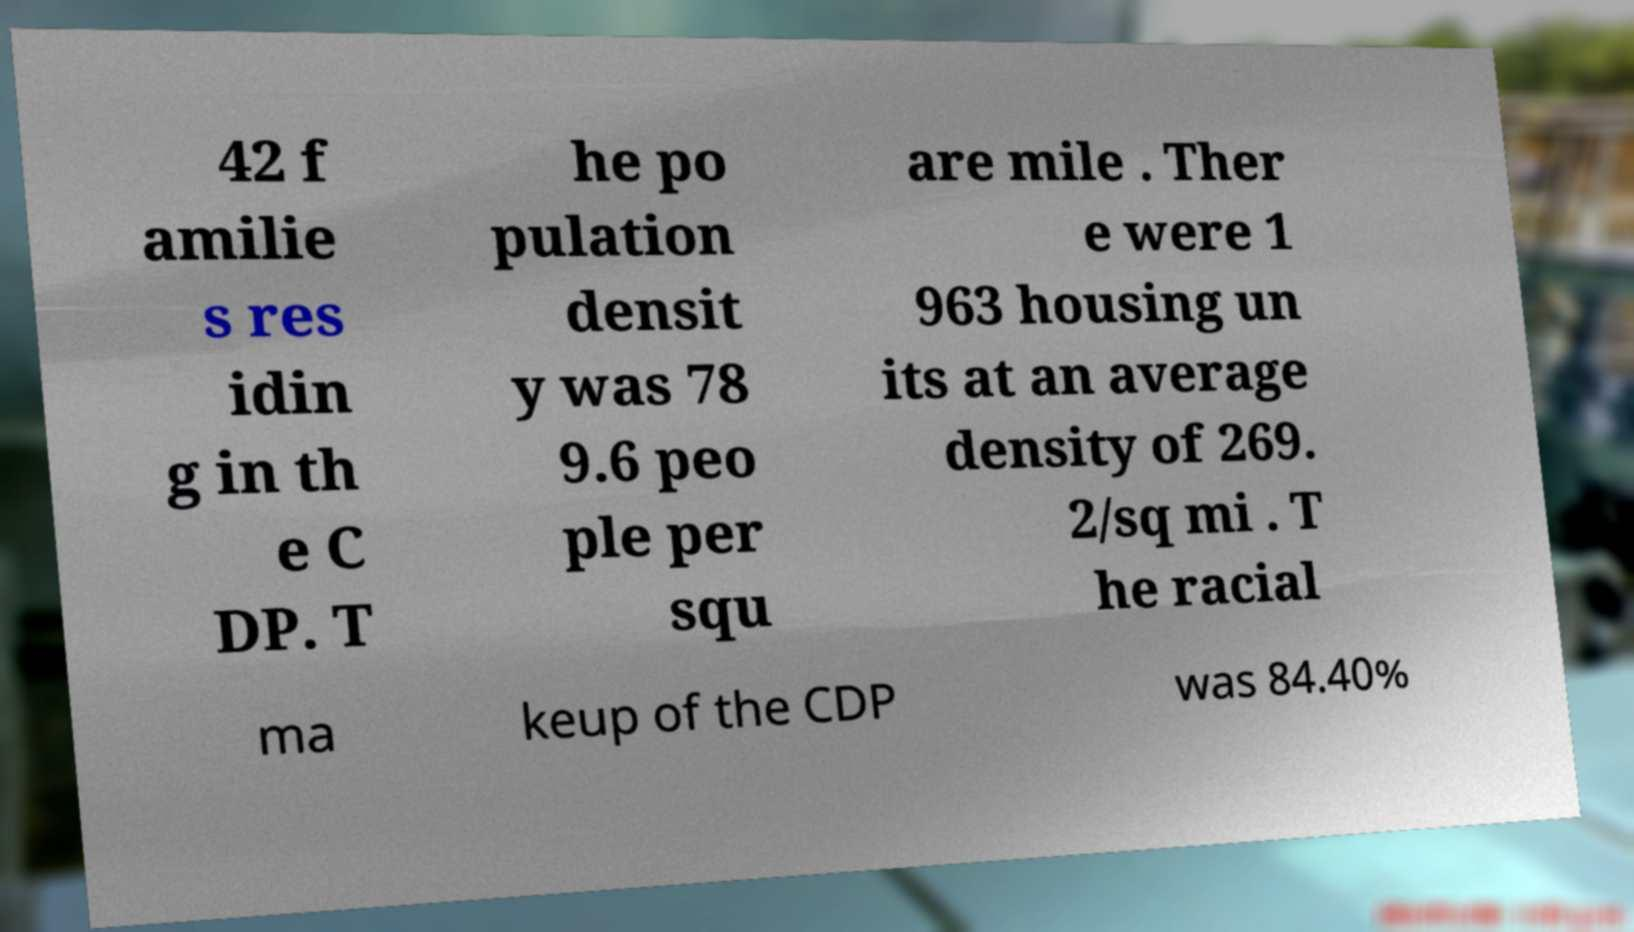Could you extract and type out the text from this image? 42 f amilie s res idin g in th e C DP. T he po pulation densit y was 78 9.6 peo ple per squ are mile . Ther e were 1 963 housing un its at an average density of 269. 2/sq mi . T he racial ma keup of the CDP was 84.40% 